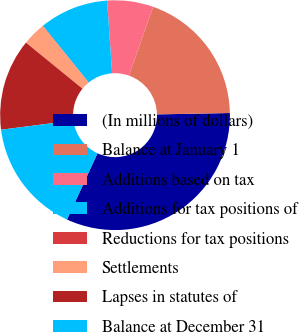<chart> <loc_0><loc_0><loc_500><loc_500><pie_chart><fcel>(In millions of dollars)<fcel>Balance at January 1<fcel>Additions based on tax<fcel>Additions for tax positions of<fcel>Reductions for tax positions<fcel>Settlements<fcel>Lapses in statutes of<fcel>Balance at December 31<nl><fcel>32.16%<fcel>19.32%<fcel>6.48%<fcel>9.69%<fcel>0.06%<fcel>3.27%<fcel>12.9%<fcel>16.11%<nl></chart> 